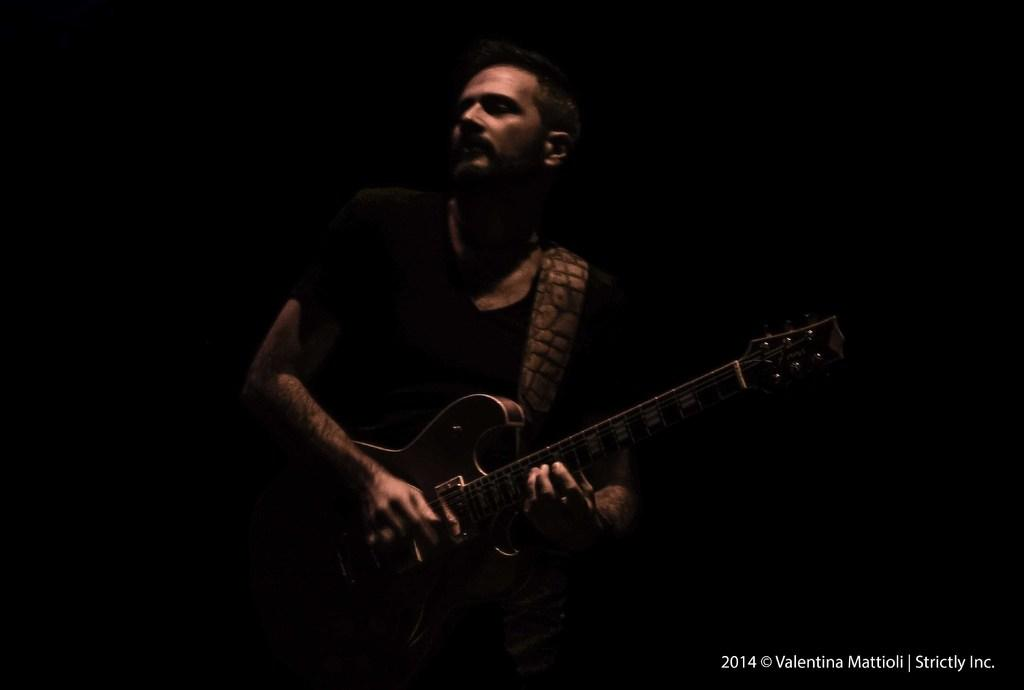What is the main subject of the image? There is a man in the image. What is the man doing in the image? The man is playing a guitar. What type of scent can be smelled coming from the man's fingers in the image? There is no indication of a scent in the image, and the man's fingers are not mentioned. 